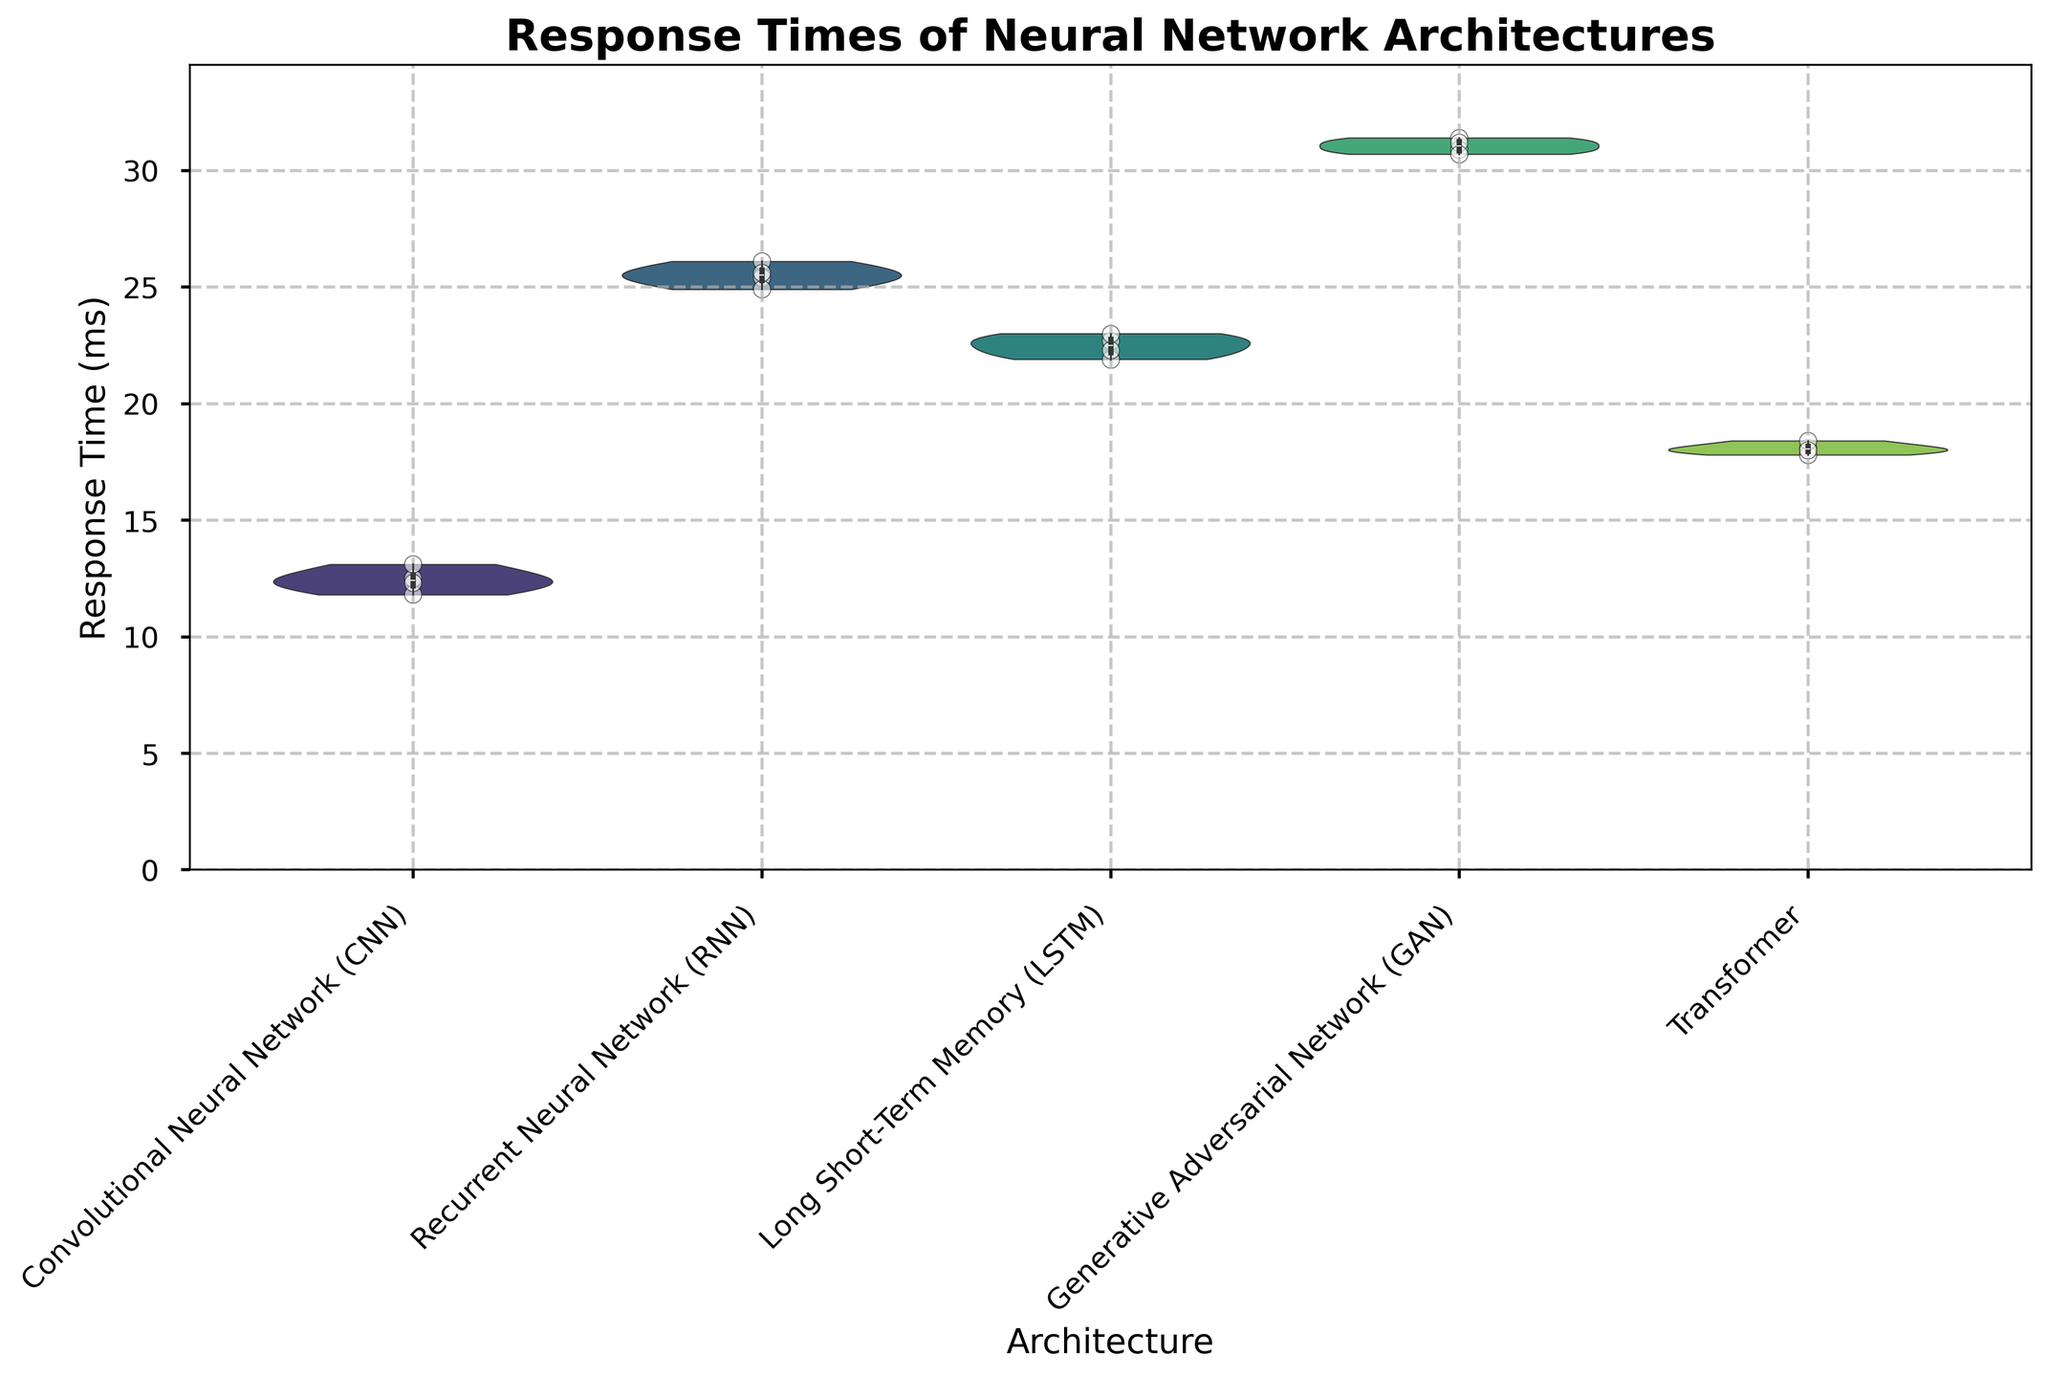What's the title of the figure? The title of the figure is generally placed at the top center, written in a larger and bold font style. In this case, the title is "Response Times of Neural Network Architectures" as noted in the provided data and code.
Answer: Response Times of Neural Network Architectures What are the labels of the x-axis and y-axis? The x-axis label is placed at the bottom, indicating what the horizontal axis represents, and the y-axis label is placed on the left side, indicating what the vertical axis represents. In this instance, the x-axis label is "Architecture" and the y-axis label is "Response Time (ms)".
Answer: Architecture; Response Time (ms) Which neural network architecture has the highest response time? To determine this, we need to look at the violins representing each architecture and compare their locations on the y-axis. The violins for Generative Adversarial Networks (GAN) are positioned the highest on the y-axis.
Answer: Generative Adversarial Network (GAN) Which architecture shows the most variability in response time? The amount of variability can be inferred from the width of the violins. The wider the violin at several points along the y-axis, the higher the variability. The GAN architecture has the widest violin, indicating the most variability.
Answer: Generative Adversarial Network (GAN) What is the median response time for the Long Short-Term Memory (LSTM) architecture? The median is visible inside the violin plot as a white dot or central value within the box. For LSTM, this white dot or central value appears around 22.5 ms.
Answer: 22.5 ms Rank the architectures based on their average response times from lowest to highest. To rank the architectures, observe the central tendency of each violin plot. The central tendency can be inferred by the median values visible inside the violins. These are approximately as follows:
1. CNN (12.5 ms)
2. Transformer (18.1 ms)
3. LSTM (22.5 ms)
4. RNN (25.4 ms)
5. GAN (31.1 ms)
Answer: CNN < Transformer < LSTM < RNN < GAN Which architecture has the smallest range of response times? The range is the vertical span of each violin plot. The range is smallest for the CNN architecture, as its violin plot is the shortest in height on the y-axis.
Answer: Convolutional Neural Network (CNN) Comparing the CNN and RNN architectures, which one has a higher variability in response times? The width of the violins (representing the distribution spread) indicates the variability. The RNN architecture shows a wider spread along the y-axis than the CNN architecture, indicating higher variability.
Answer: Recurrent Neural Network (RNN) Are there any architectures whose response times overlap significantly? Overlapping can be inferred if the violins have substantial vertical spans that coincide. The response times for LSTM and transformer architectures overlap significantly between the ranges of 17.5 ms and 23.5 ms.
Answer: Yes, LSTM and Transformer 